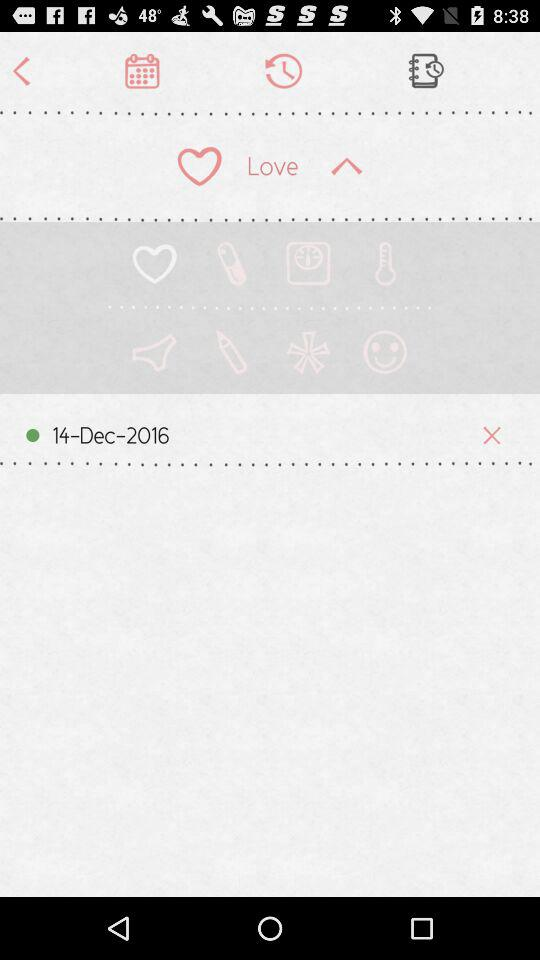What is the status of the "Show password"? The status of the "Show password" is "off". 